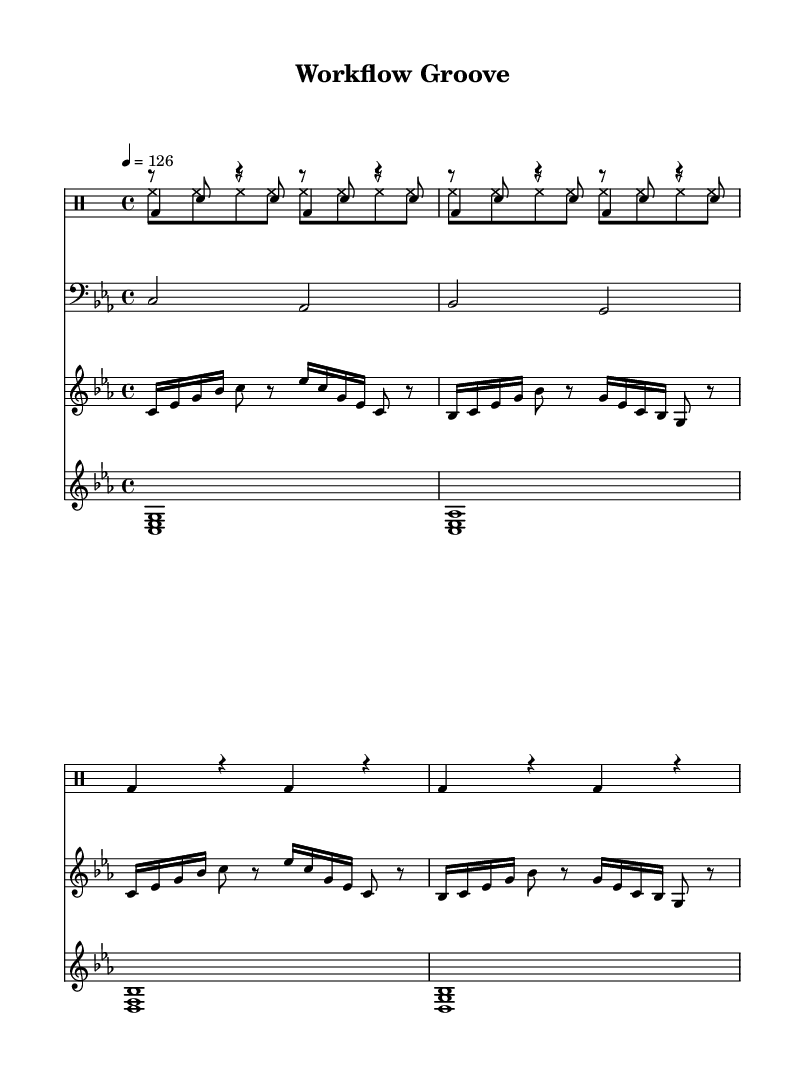What is the key signature of this music? The key signature of the music is C minor, indicated by three flats. This can be identified at the beginning of the staff where the flats are placed.
Answer: C minor What is the time signature of this piece? The time signature displayed at the beginning of the music is 4/4, meaning there are four beats in each measure and the quarter note receives one beat.
Answer: 4/4 What is the tempo marking for this composition? The tempo marking is 126 beats per minute, which is indicated next to the tempo indication in the score.
Answer: 126 How many measures does the kick drum part repeat? The kick drum part repeats for a total of four measures, shown by the repeat sign and the notation for the kick drum.
Answer: 4 Which instrument plays the bass notes in this piece? The bass notes are played by the bass synth, as indicated by the clef and instrument name above the corresponding staff.
Answer: Bass synth What type of rhythm does the hi-hat pattern have? The hi-hat pattern consists of eighth notes, as indicated by the note type shown in the hi-hat part, which is marked with the appropriate rhythmic notation.
Answer: Eighth notes How many different synth parts are featured in this piece? There are three different synth parts presented in the score: lead synth, bass synth, and pad synth, as seen in their respective staves.
Answer: Three 